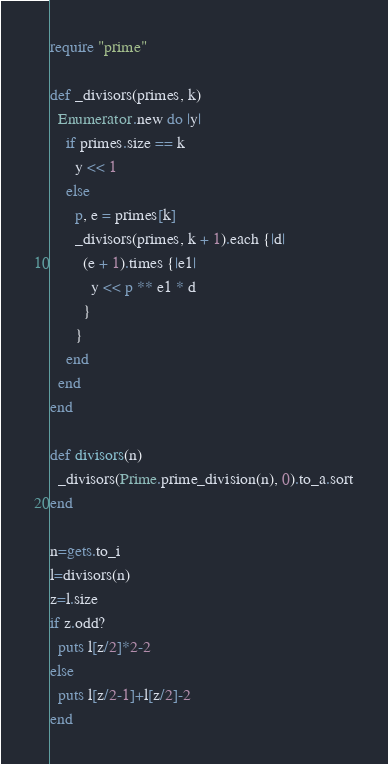<code> <loc_0><loc_0><loc_500><loc_500><_Ruby_>require "prime"

def _divisors(primes, k)
  Enumerator.new do |y|
    if primes.size == k
      y << 1
    else
      p, e = primes[k]
      _divisors(primes, k + 1).each {|d|
        (e + 1).times {|e1|
          y << p ** e1 * d
        }
      }
    end
  end
end

def divisors(n)
  _divisors(Prime.prime_division(n), 0).to_a.sort
end

n=gets.to_i
l=divisors(n)
z=l.size
if z.odd?
  puts l[z/2]*2-2
else
  puts l[z/2-1]+l[z/2]-2
end</code> 